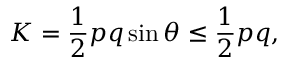Convert formula to latex. <formula><loc_0><loc_0><loc_500><loc_500>K = { \frac { 1 } { 2 } } p q \sin { \theta } \leq { \frac { 1 } { 2 } } p q ,</formula> 